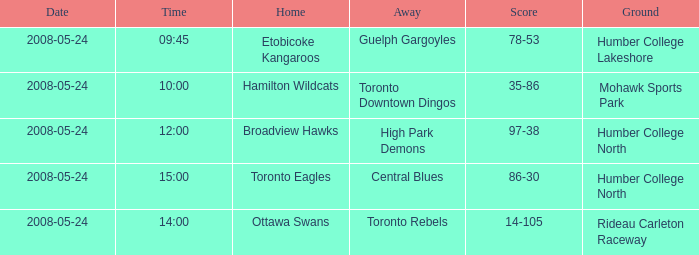Who was the away team of the game at the time 15:00? Central Blues. 